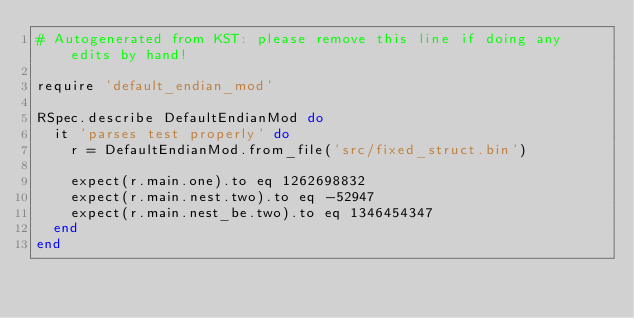Convert code to text. <code><loc_0><loc_0><loc_500><loc_500><_Ruby_># Autogenerated from KST: please remove this line if doing any edits by hand!

require 'default_endian_mod'

RSpec.describe DefaultEndianMod do
  it 'parses test properly' do
    r = DefaultEndianMod.from_file('src/fixed_struct.bin')

    expect(r.main.one).to eq 1262698832
    expect(r.main.nest.two).to eq -52947
    expect(r.main.nest_be.two).to eq 1346454347
  end
end
</code> 